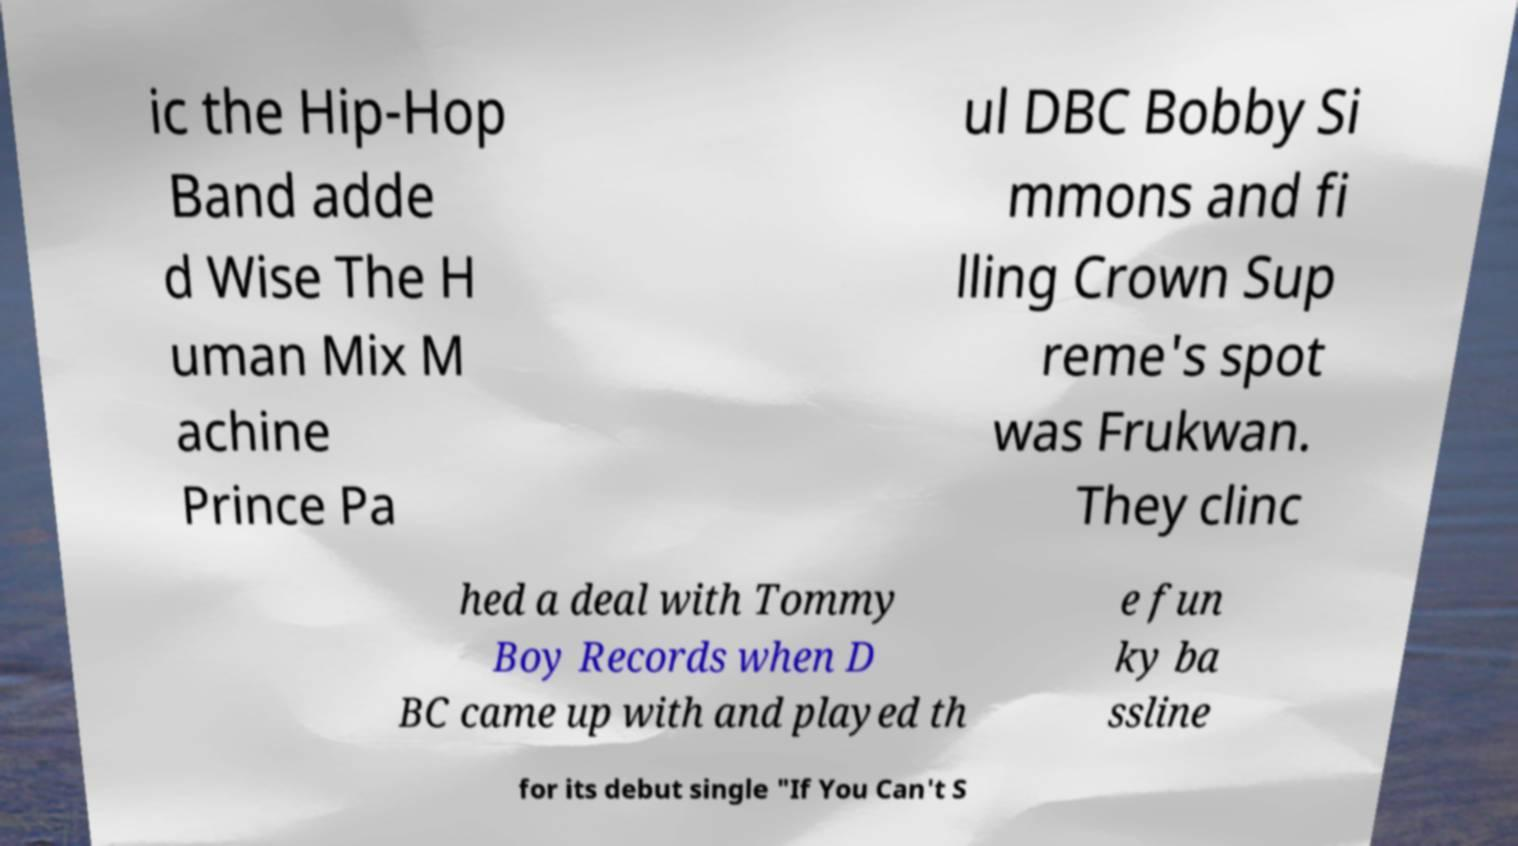Please read and relay the text visible in this image. What does it say? ic the Hip-Hop Band adde d Wise The H uman Mix M achine Prince Pa ul DBC Bobby Si mmons and fi lling Crown Sup reme's spot was Frukwan. They clinc hed a deal with Tommy Boy Records when D BC came up with and played th e fun ky ba ssline for its debut single "If You Can't S 